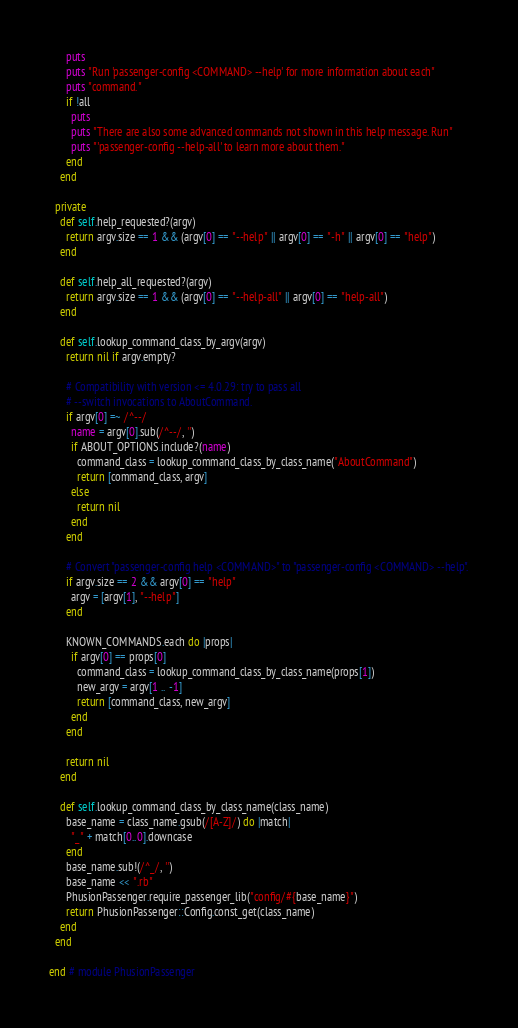Convert code to text. <code><loc_0><loc_0><loc_500><loc_500><_Ruby_>      puts
      puts "Run 'passenger-config <COMMAND> --help' for more information about each"
      puts "command."
      if !all
        puts
        puts "There are also some advanced commands not shown in this help message. Run"
        puts "'passenger-config --help-all' to learn more about them."
      end
    end

  private
    def self.help_requested?(argv)
      return argv.size == 1 && (argv[0] == "--help" || argv[0] == "-h" || argv[0] == "help")
    end

    def self.help_all_requested?(argv)
      return argv.size == 1 && (argv[0] == "--help-all" || argv[0] == "help-all")
    end

    def self.lookup_command_class_by_argv(argv)
      return nil if argv.empty?

      # Compatibility with version <= 4.0.29: try to pass all
      # --switch invocations to AboutCommand.
      if argv[0] =~ /^--/
        name = argv[0].sub(/^--/, '')
        if ABOUT_OPTIONS.include?(name)
          command_class = lookup_command_class_by_class_name("AboutCommand")
          return [command_class, argv]
        else
          return nil
        end
      end

      # Convert "passenger-config help <COMMAND>" to "passenger-config <COMMAND> --help".
      if argv.size == 2 && argv[0] == "help"
        argv = [argv[1], "--help"]
      end

      KNOWN_COMMANDS.each do |props|
        if argv[0] == props[0]
          command_class = lookup_command_class_by_class_name(props[1])
          new_argv = argv[1 .. -1]
          return [command_class, new_argv]
        end
      end

      return nil
    end

    def self.lookup_command_class_by_class_name(class_name)
      base_name = class_name.gsub(/[A-Z]/) do |match|
        "_" + match[0..0].downcase
      end
      base_name.sub!(/^_/, '')
      base_name << ".rb"
      PhusionPassenger.require_passenger_lib("config/#{base_name}")
      return PhusionPassenger::Config.const_get(class_name)
    end
  end

end # module PhusionPassenger
</code> 